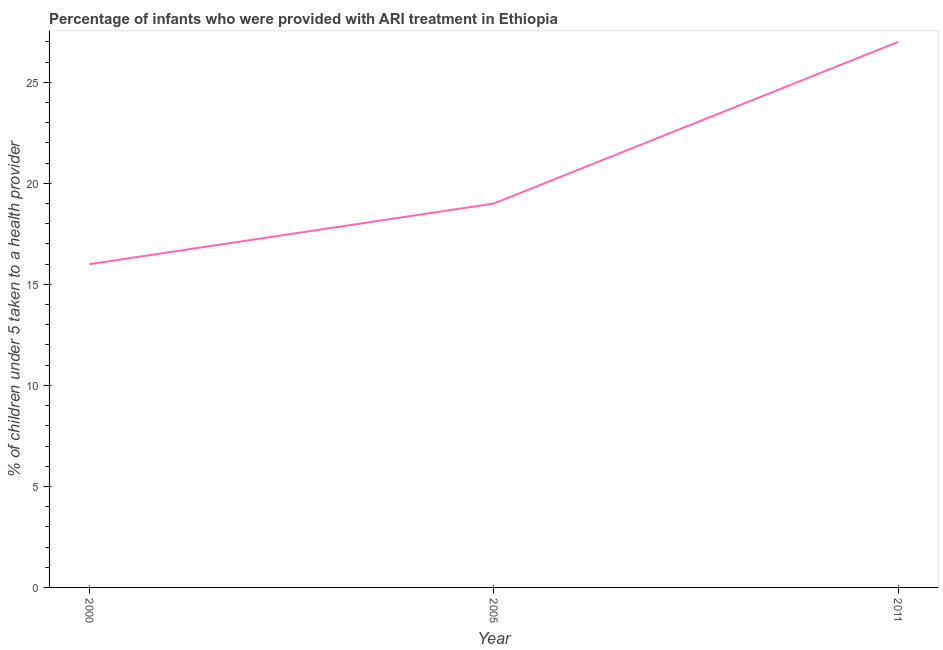What is the percentage of children who were provided with ari treatment in 2000?
Your answer should be very brief. 16. Across all years, what is the maximum percentage of children who were provided with ari treatment?
Your response must be concise. 27. Across all years, what is the minimum percentage of children who were provided with ari treatment?
Provide a short and direct response. 16. In which year was the percentage of children who were provided with ari treatment maximum?
Offer a very short reply. 2011. In which year was the percentage of children who were provided with ari treatment minimum?
Provide a succinct answer. 2000. What is the sum of the percentage of children who were provided with ari treatment?
Give a very brief answer. 62. What is the difference between the percentage of children who were provided with ari treatment in 2000 and 2005?
Your response must be concise. -3. What is the average percentage of children who were provided with ari treatment per year?
Your answer should be very brief. 20.67. In how many years, is the percentage of children who were provided with ari treatment greater than 22 %?
Make the answer very short. 1. What is the ratio of the percentage of children who were provided with ari treatment in 2000 to that in 2005?
Provide a short and direct response. 0.84. Is the percentage of children who were provided with ari treatment in 2000 less than that in 2005?
Make the answer very short. Yes. Is the difference between the percentage of children who were provided with ari treatment in 2000 and 2011 greater than the difference between any two years?
Your answer should be very brief. Yes. Is the sum of the percentage of children who were provided with ari treatment in 2000 and 2011 greater than the maximum percentage of children who were provided with ari treatment across all years?
Ensure brevity in your answer.  Yes. What is the difference between the highest and the lowest percentage of children who were provided with ari treatment?
Your answer should be very brief. 11. In how many years, is the percentage of children who were provided with ari treatment greater than the average percentage of children who were provided with ari treatment taken over all years?
Offer a very short reply. 1. How many years are there in the graph?
Your response must be concise. 3. What is the difference between two consecutive major ticks on the Y-axis?
Your response must be concise. 5. Does the graph contain grids?
Make the answer very short. No. What is the title of the graph?
Provide a short and direct response. Percentage of infants who were provided with ARI treatment in Ethiopia. What is the label or title of the X-axis?
Provide a succinct answer. Year. What is the label or title of the Y-axis?
Your response must be concise. % of children under 5 taken to a health provider. What is the % of children under 5 taken to a health provider of 2000?
Provide a succinct answer. 16. What is the % of children under 5 taken to a health provider of 2011?
Give a very brief answer. 27. What is the difference between the % of children under 5 taken to a health provider in 2000 and 2011?
Your answer should be compact. -11. What is the difference between the % of children under 5 taken to a health provider in 2005 and 2011?
Your response must be concise. -8. What is the ratio of the % of children under 5 taken to a health provider in 2000 to that in 2005?
Provide a succinct answer. 0.84. What is the ratio of the % of children under 5 taken to a health provider in 2000 to that in 2011?
Your response must be concise. 0.59. What is the ratio of the % of children under 5 taken to a health provider in 2005 to that in 2011?
Ensure brevity in your answer.  0.7. 